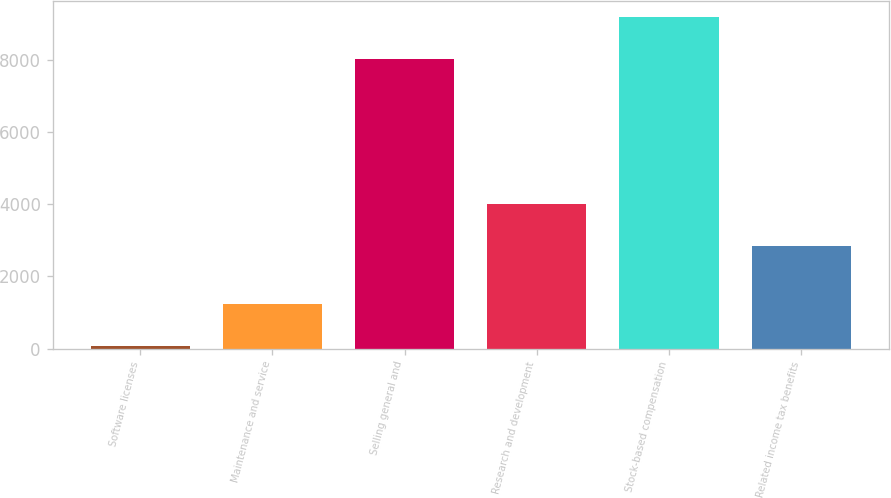<chart> <loc_0><loc_0><loc_500><loc_500><bar_chart><fcel>Software licenses<fcel>Maintenance and service<fcel>Selling general and<fcel>Research and development<fcel>Stock-based compensation<fcel>Related income tax benefits<nl><fcel>72<fcel>1242.7<fcel>8022<fcel>4003.7<fcel>9192.7<fcel>2833<nl></chart> 